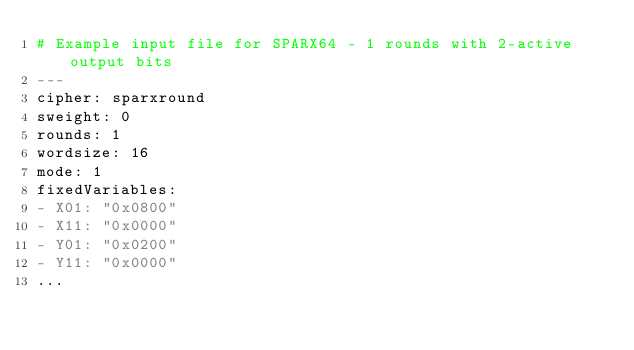Convert code to text. <code><loc_0><loc_0><loc_500><loc_500><_YAML_># Example input file for SPARX64 - 1 rounds with 2-active output bits
---
cipher: sparxround
sweight: 0
rounds: 1
wordsize: 16
mode: 1
fixedVariables:
- X01: "0x0800"
- X11: "0x0000"
- Y01: "0x0200"
- Y11: "0x0000"
...

</code> 